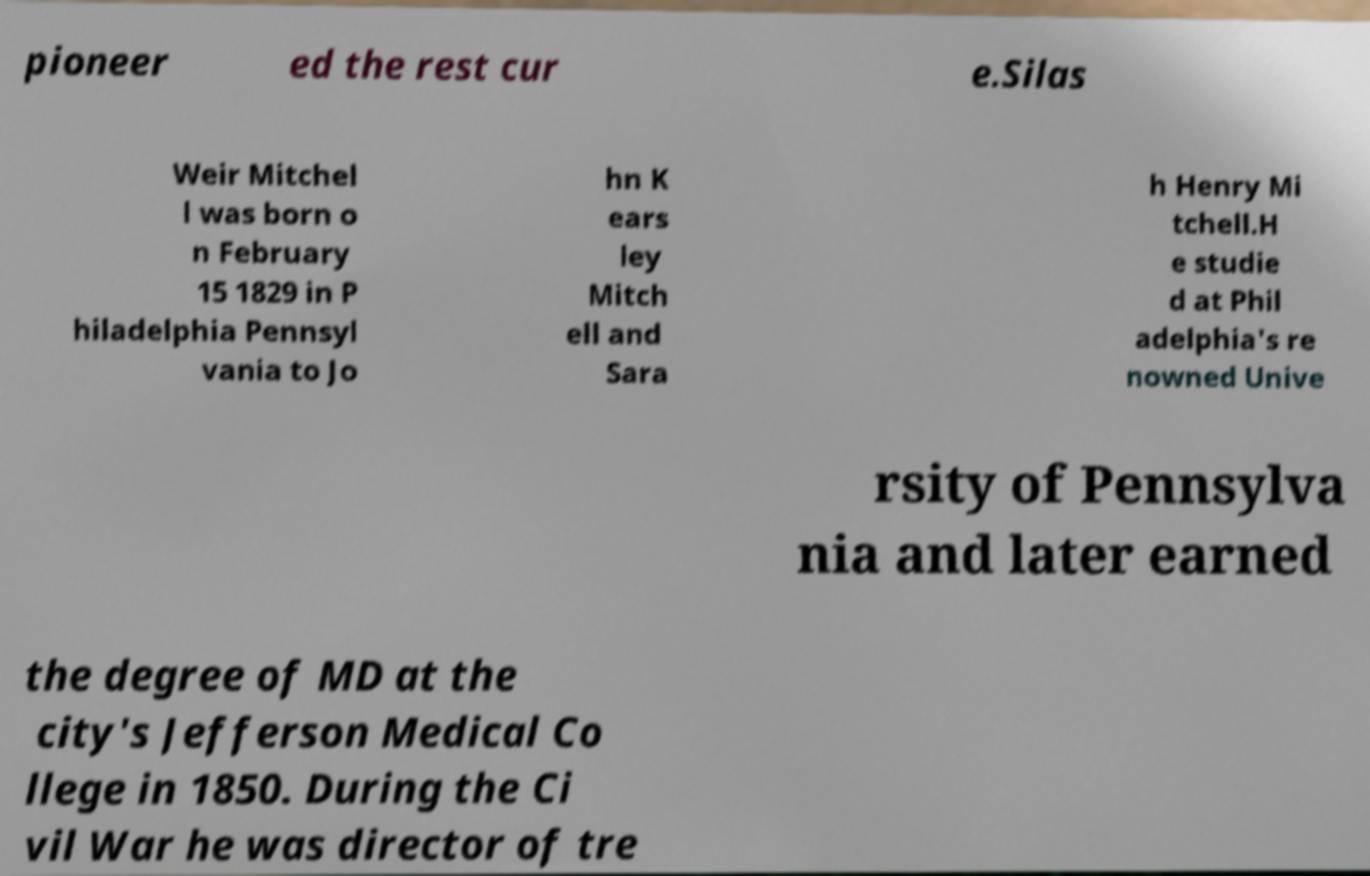Please identify and transcribe the text found in this image. pioneer ed the rest cur e.Silas Weir Mitchel l was born o n February 15 1829 in P hiladelphia Pennsyl vania to Jo hn K ears ley Mitch ell and Sara h Henry Mi tchell.H e studie d at Phil adelphia's re nowned Unive rsity of Pennsylva nia and later earned the degree of MD at the city's Jefferson Medical Co llege in 1850. During the Ci vil War he was director of tre 